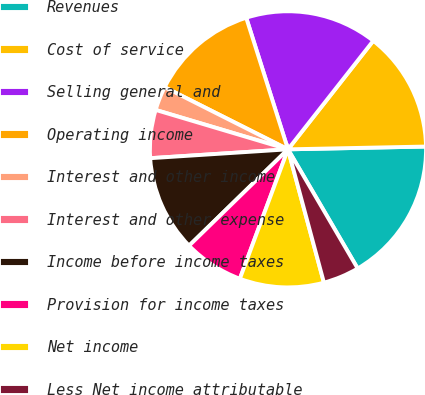<chart> <loc_0><loc_0><loc_500><loc_500><pie_chart><fcel>Revenues<fcel>Cost of service<fcel>Selling general and<fcel>Operating income<fcel>Interest and other income<fcel>Interest and other expense<fcel>Income before income taxes<fcel>Provision for income taxes<fcel>Net income<fcel>Less Net income attributable<nl><fcel>16.9%<fcel>14.08%<fcel>15.49%<fcel>12.68%<fcel>2.82%<fcel>5.63%<fcel>11.27%<fcel>7.04%<fcel>9.86%<fcel>4.23%<nl></chart> 